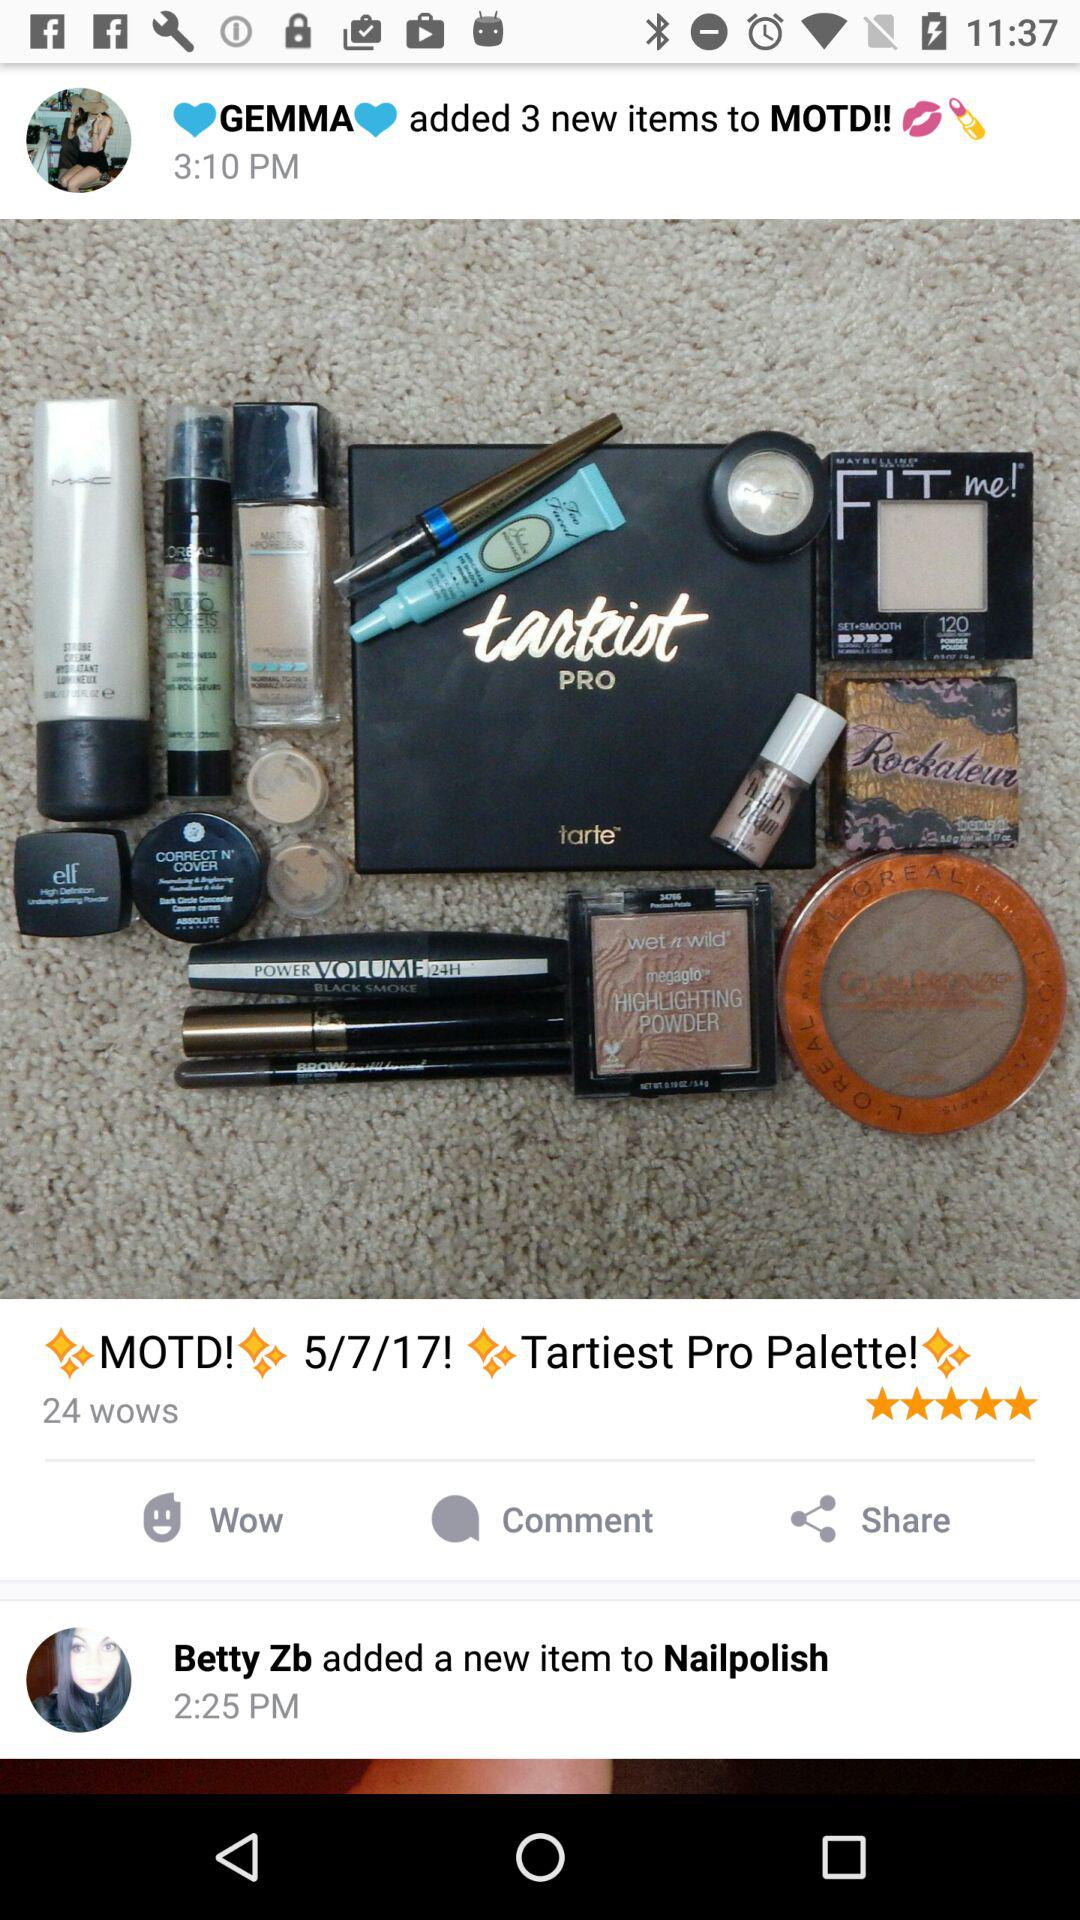How many wows are there? There are 24 wows. 